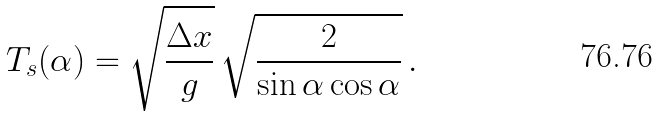<formula> <loc_0><loc_0><loc_500><loc_500>T _ { s } ( \alpha ) = \sqrt { \frac { \Delta x } { g } } \, \sqrt { \frac { 2 } { \sin \alpha \cos \alpha } } \, .</formula> 